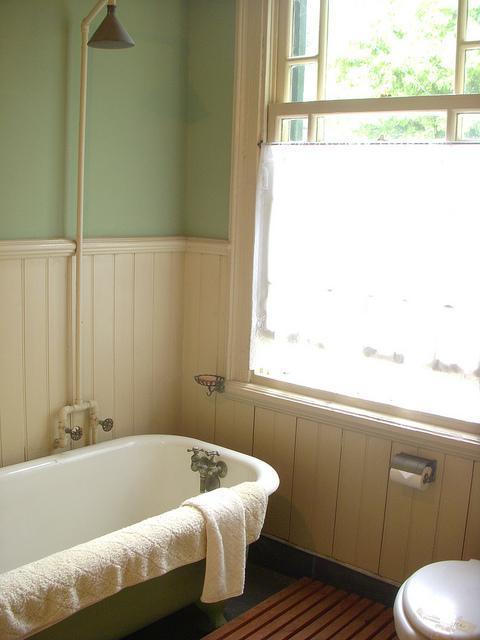How many towels are shown?
Give a very brief answer. 2. How many windows are in the photo?
Give a very brief answer. 1. How many people fit in the tub?
Give a very brief answer. 1. 